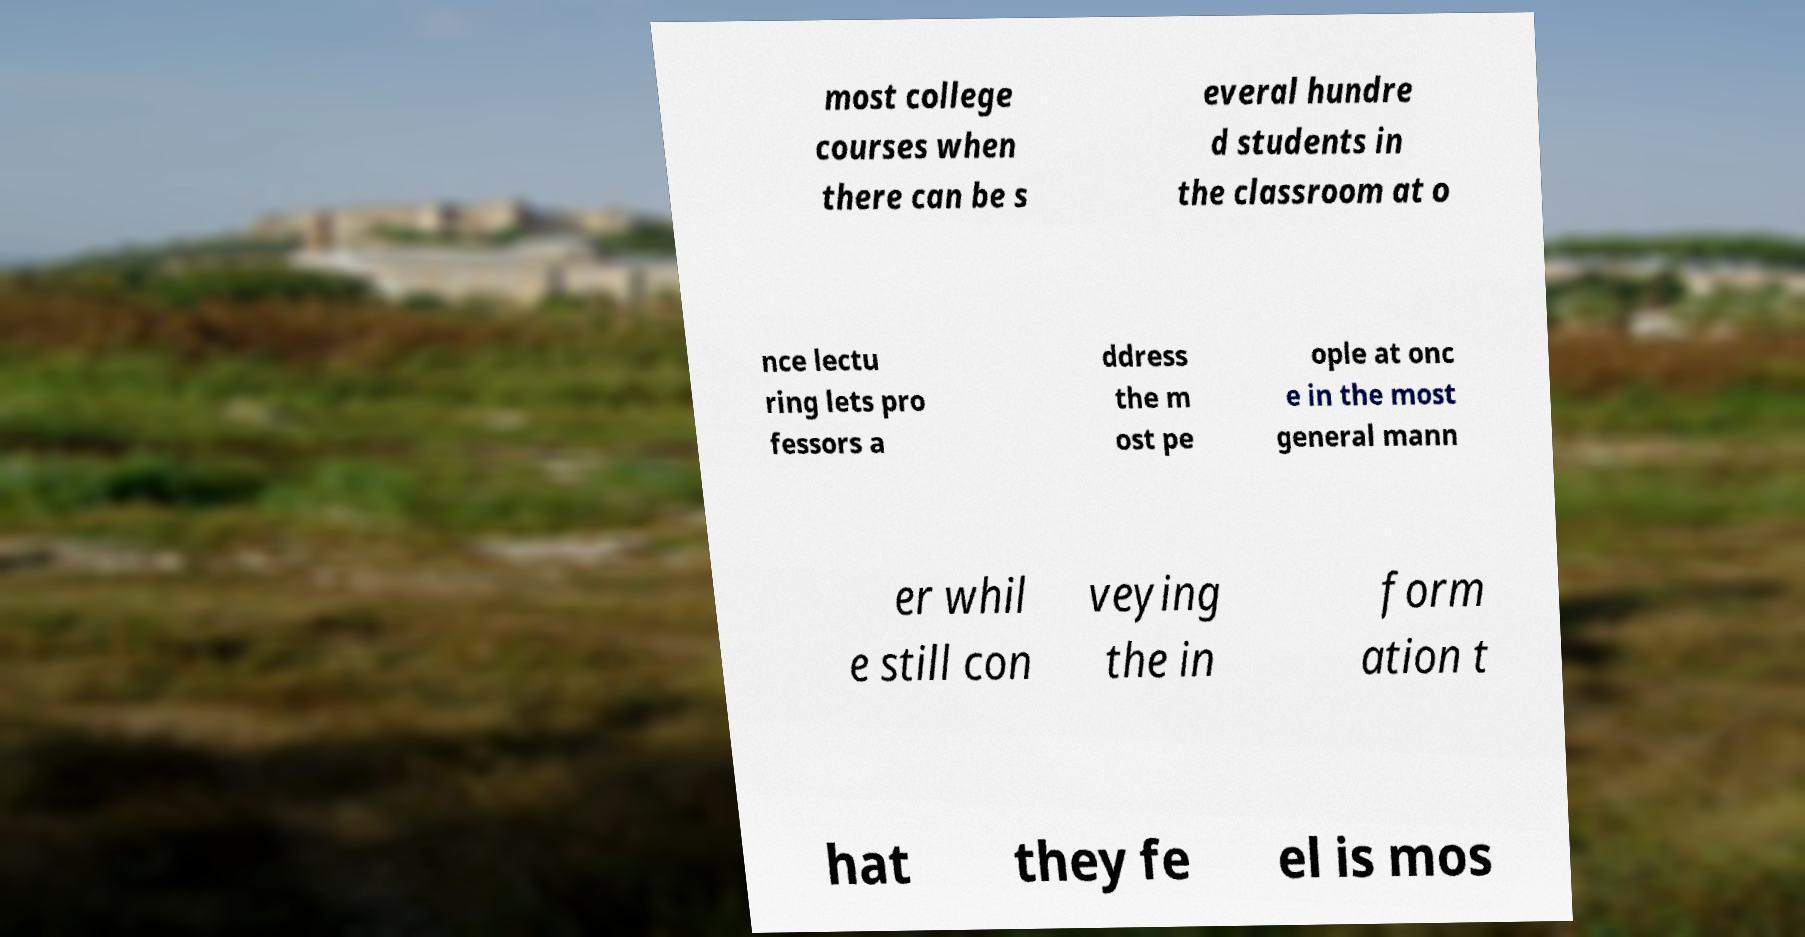Please read and relay the text visible in this image. What does it say? most college courses when there can be s everal hundre d students in the classroom at o nce lectu ring lets pro fessors a ddress the m ost pe ople at onc e in the most general mann er whil e still con veying the in form ation t hat they fe el is mos 